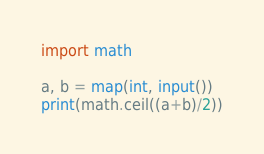<code> <loc_0><loc_0><loc_500><loc_500><_Python_>import math

a, b = map(int, input())
print(math.ceil((a+b)/2))</code> 